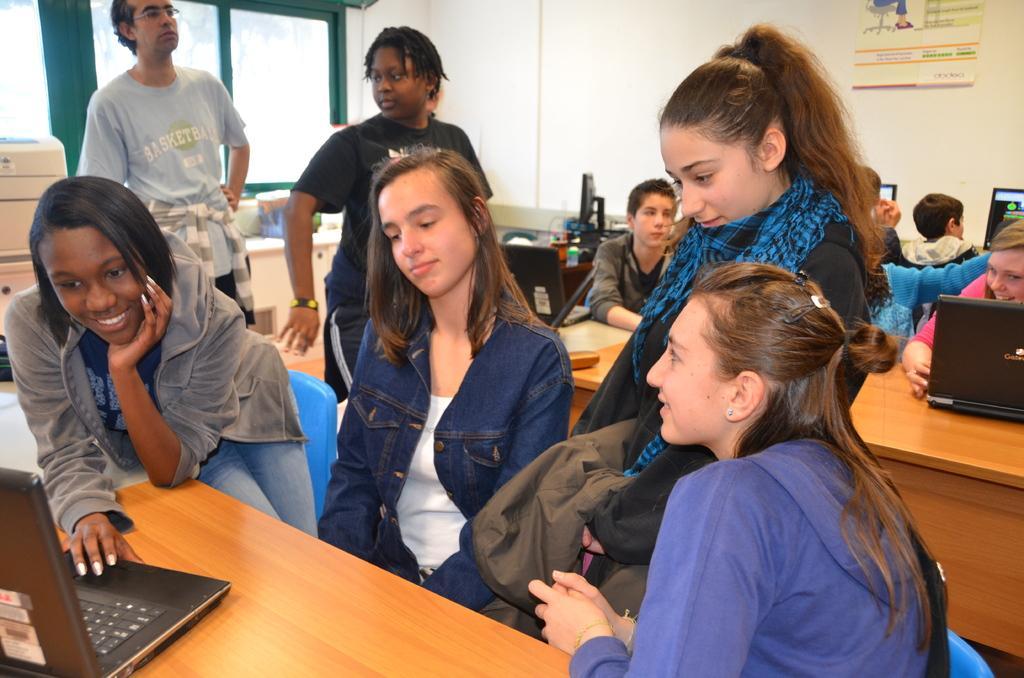In one or two sentences, can you explain what this image depicts? This image is taken in indoors. There are few people in this image. In the left side of the image a girl is standing in front of the table and looking at laptop. In the right side of the image a girl is sitting on a chair. In the middle of the image a girl is sitting and a man is standing. At the background there is a wall and windows. 